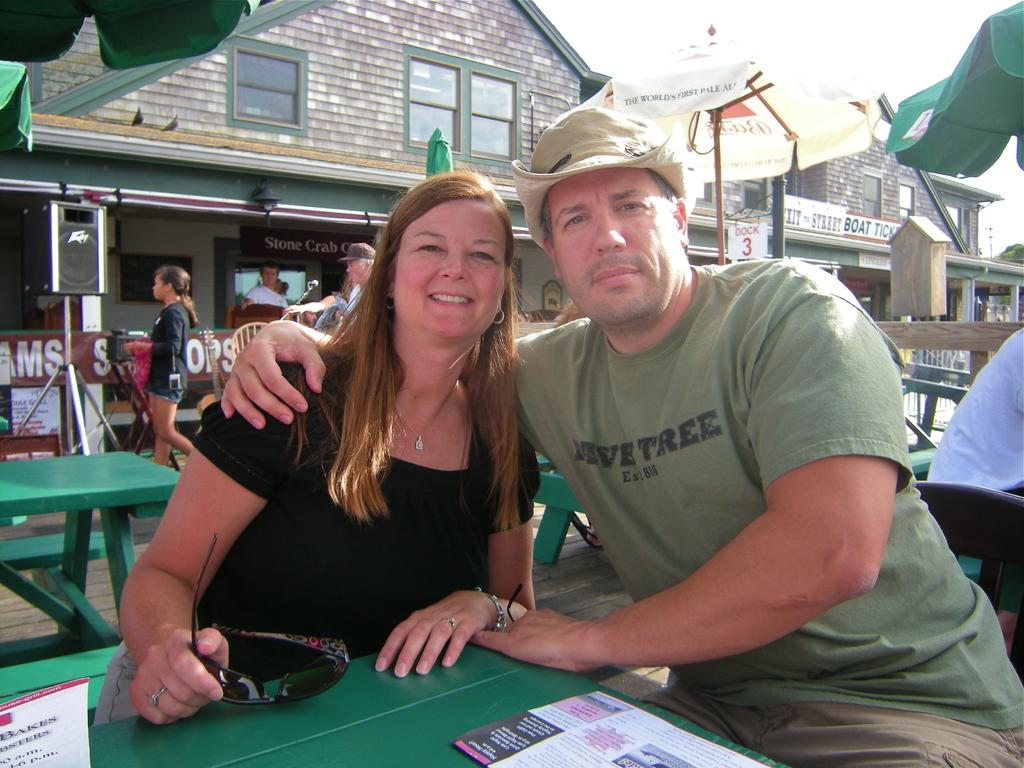How many people are sitting on the bench in the image? There are two people sitting on a bench in the image. What is present on the bench with the people? There is a table in the image. What is on the table? There is a paper on the table. What can be seen in the background of the image? There is a building visible in the background. What type of beef is being served at the meeting in the image? There is no beef or meeting present in the image; it features two people sitting on a bench with a table and a paper. 